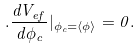Convert formula to latex. <formula><loc_0><loc_0><loc_500><loc_500>. \frac { d V _ { e f } } { d \phi _ { c } } | _ { \phi _ { c } = \langle \phi \rangle } = 0 .</formula> 